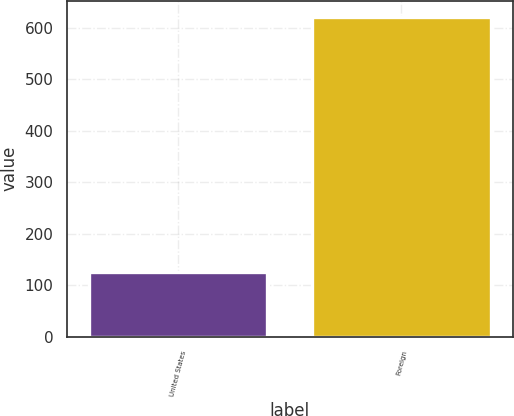<chart> <loc_0><loc_0><loc_500><loc_500><bar_chart><fcel>United States<fcel>Foreign<nl><fcel>125<fcel>622<nl></chart> 